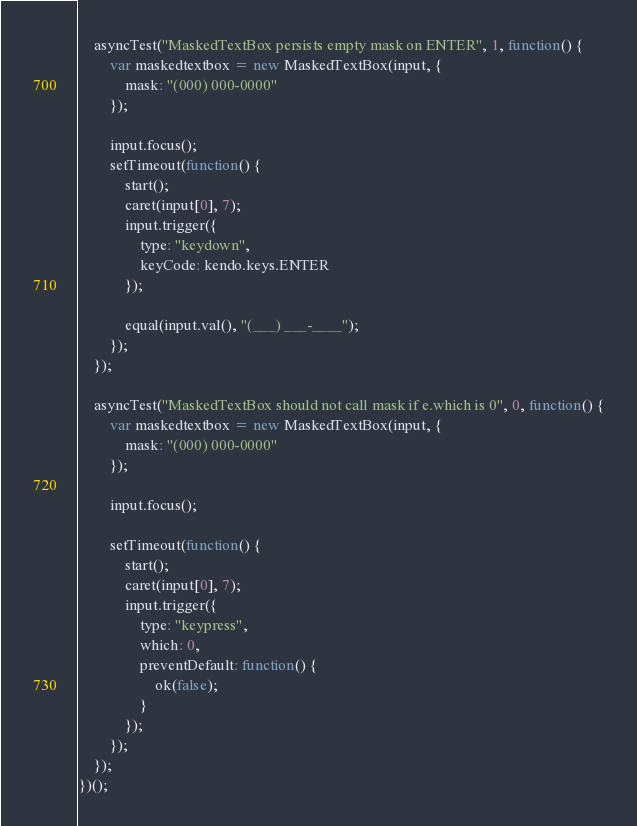Convert code to text. <code><loc_0><loc_0><loc_500><loc_500><_JavaScript_>    asyncTest("MaskedTextBox persists empty mask on ENTER", 1, function() {
        var maskedtextbox = new MaskedTextBox(input, {
            mask: "(000) 000-0000"
        });

        input.focus();
        setTimeout(function() {
            start();
            caret(input[0], 7);
            input.trigger({
                type: "keydown",
                keyCode: kendo.keys.ENTER
            });

            equal(input.val(), "(___) ___-____");
        });
    });

    asyncTest("MaskedTextBox should not call mask if e.which is 0", 0, function() {
        var maskedtextbox = new MaskedTextBox(input, {
            mask: "(000) 000-0000"
        });

        input.focus();

        setTimeout(function() {
            start();
            caret(input[0], 7);
            input.trigger({
                type: "keypress",
                which: 0,
                preventDefault: function() {
                    ok(false);
                }
            });
        });
    });
})();
</code> 